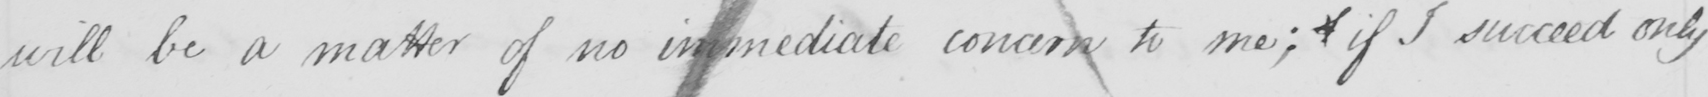What is written in this line of handwriting? will be a matter of no immediate concern to me; if I succeed only 